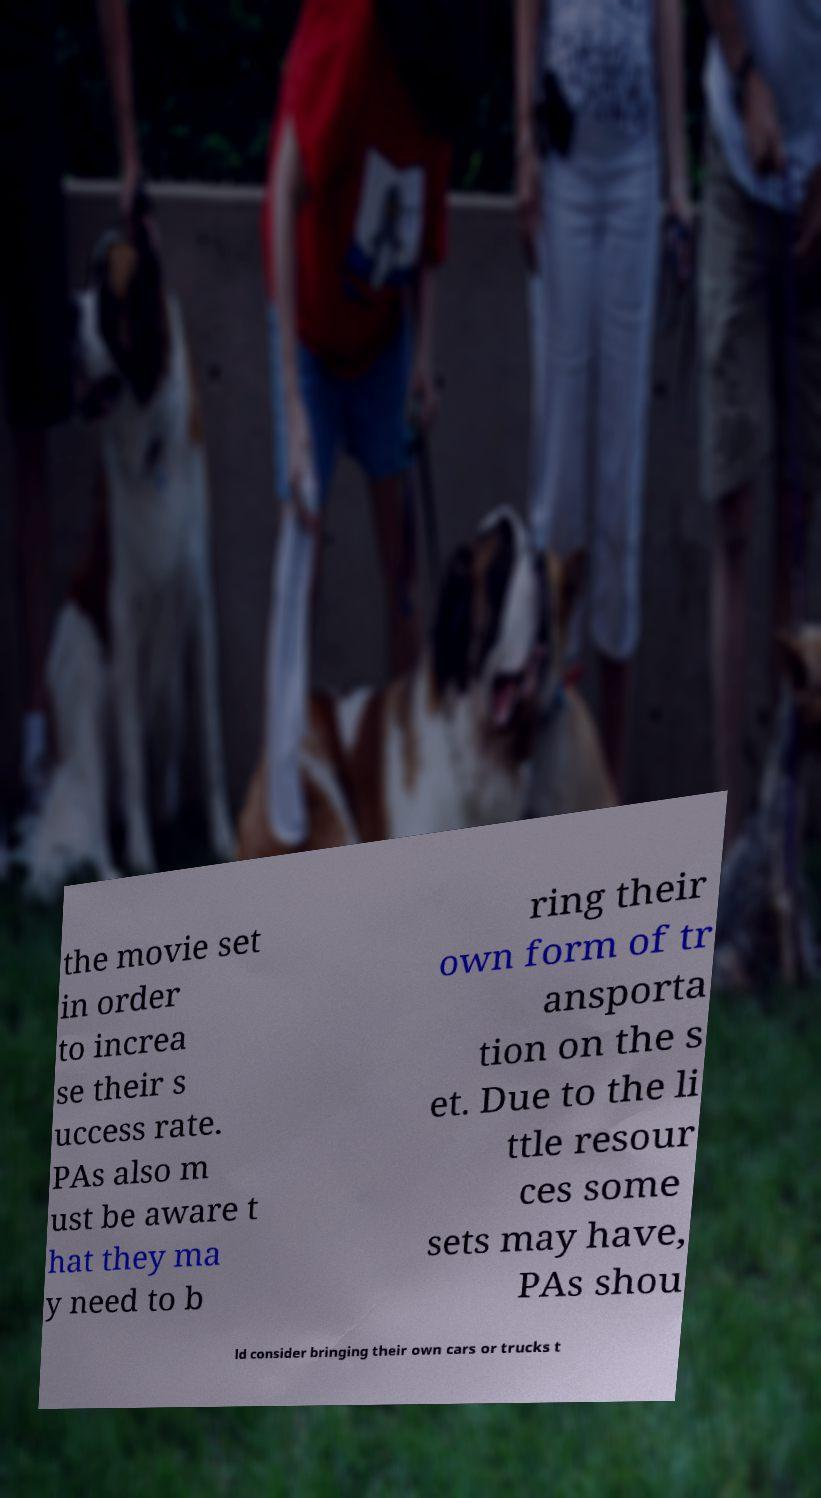I need the written content from this picture converted into text. Can you do that? the movie set in order to increa se their s uccess rate. PAs also m ust be aware t hat they ma y need to b ring their own form of tr ansporta tion on the s et. Due to the li ttle resour ces some sets may have, PAs shou ld consider bringing their own cars or trucks t 